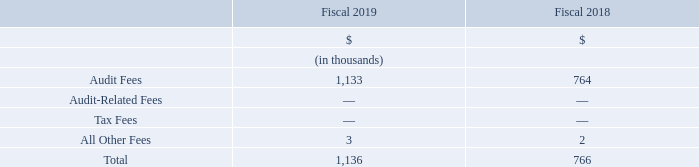Auditor Service Fees
The aggregate amounts paid or accrued by the Company with respect to fees payable to PricewaterhouseCoopers LLP, the auditors of the Company, for audit (including separate audits of wholly-owned and non-wholly owned entities, financings, regulatory reporting requirements and SOX related services), audit-related, tax and other services in the years ended December 31, 2019 and 2018 were as follows:
Audit fees relate to the audit of our annual consolidated financial statements, the review of our quarterly condensed consolidated financial statements and services in connection with our 2019 and 2018 public offerings of Class A subordinate voting shares
Audit-related fees consist of aggregate fees for accounting consultations and other services that were reasonably related to the performance of audits or reviews of our consolidated financial statements and were not reported above under "Audit Fees".
Tax fees relate to assistance with tax compliance, expatriate tax return preparation, tax planning and various tax advisory services.
Other fees are any additional amounts for products and services provided by the principal accountants other than the services reported above under "Audit Fees", "Audit-Related Fees" and "Tax Fees".
Which financial years' information is shown in the table? 2018, 2019. Which financial items are listed in the table? Audit fees, audit-related fees, tax fees, all other fees. What is the audit fees for fiscal 2019?
Answer scale should be: thousand. 1,133. What is the average audit fees for 2018 and 2019?
Answer scale should be: thousand. (1,133+764)/2
Answer: 948.5. What is the average total auditor service fees for 2018 and 2019?
Answer scale should be: thousand. (1,136+766)/2
Answer: 951. Between fiscal 2018 and 2019, which year had higher audit fees? 1,133>764
Answer: 2019. 